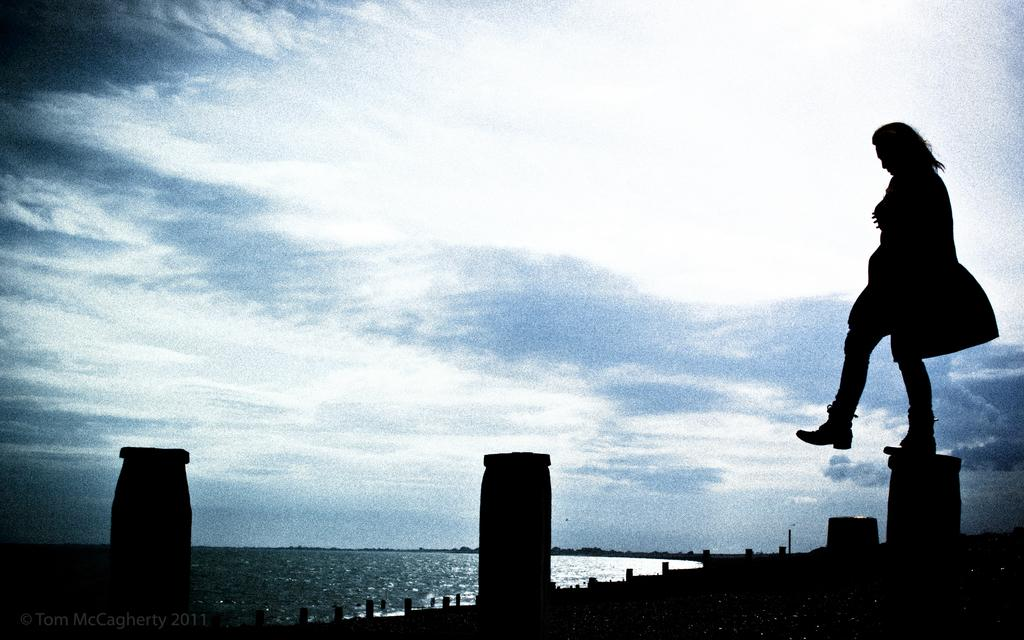What is the overall lighting condition in the image? The image is dark. What objects can be seen in the image? There are poles in the image. What is the person in the image doing? A person is standing on one of the poles. What natural element is visible in the image? There is water visible in the image. What can be seen in the background of the image? The sky is visible in the background of the image. What type of pen is the person holding in the image? There is no pen present in the image; the person is standing on a pole. What feeling does the person on the pole express in the image? The image does not convey any specific feelings or emotions of the person on the pole. 